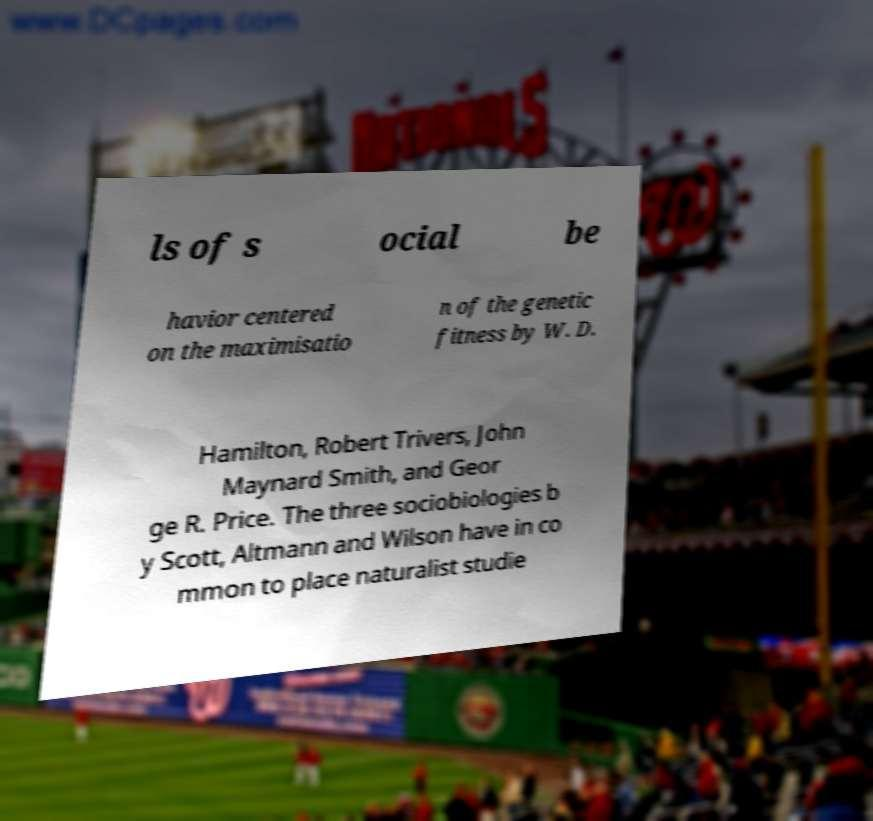Can you read and provide the text displayed in the image?This photo seems to have some interesting text. Can you extract and type it out for me? ls of s ocial be havior centered on the maximisatio n of the genetic fitness by W. D. Hamilton, Robert Trivers, John Maynard Smith, and Geor ge R. Price. The three sociobiologies b y Scott, Altmann and Wilson have in co mmon to place naturalist studie 